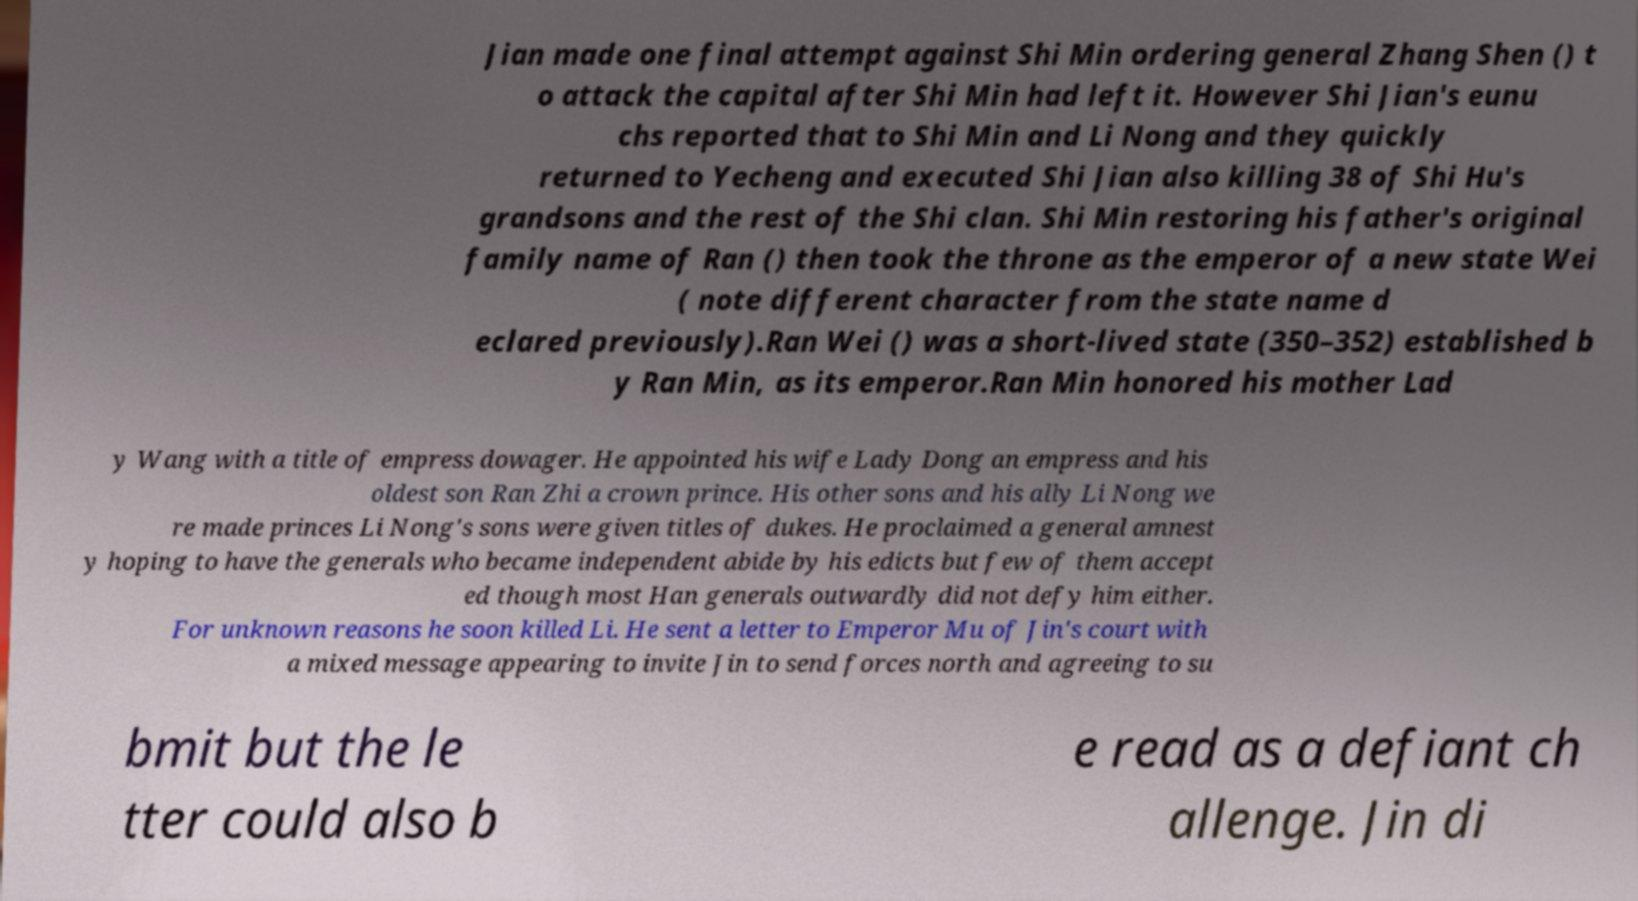Could you assist in decoding the text presented in this image and type it out clearly? Jian made one final attempt against Shi Min ordering general Zhang Shen () t o attack the capital after Shi Min had left it. However Shi Jian's eunu chs reported that to Shi Min and Li Nong and they quickly returned to Yecheng and executed Shi Jian also killing 38 of Shi Hu's grandsons and the rest of the Shi clan. Shi Min restoring his father's original family name of Ran () then took the throne as the emperor of a new state Wei ( note different character from the state name d eclared previously).Ran Wei () was a short-lived state (350–352) established b y Ran Min, as its emperor.Ran Min honored his mother Lad y Wang with a title of empress dowager. He appointed his wife Lady Dong an empress and his oldest son Ran Zhi a crown prince. His other sons and his ally Li Nong we re made princes Li Nong's sons were given titles of dukes. He proclaimed a general amnest y hoping to have the generals who became independent abide by his edicts but few of them accept ed though most Han generals outwardly did not defy him either. For unknown reasons he soon killed Li. He sent a letter to Emperor Mu of Jin's court with a mixed message appearing to invite Jin to send forces north and agreeing to su bmit but the le tter could also b e read as a defiant ch allenge. Jin di 